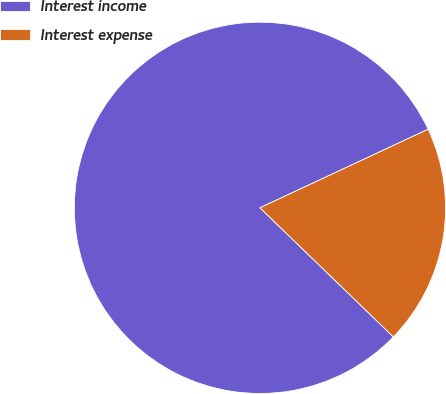Convert chart. <chart><loc_0><loc_0><loc_500><loc_500><pie_chart><fcel>Interest income<fcel>Interest expense<nl><fcel>80.81%<fcel>19.19%<nl></chart> 